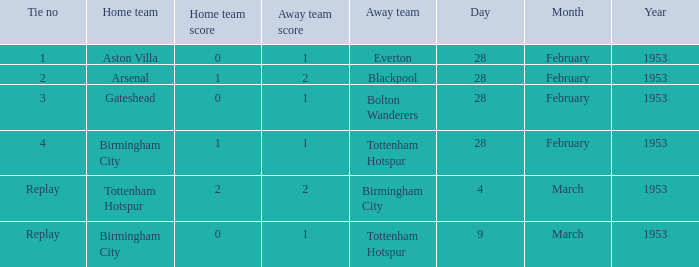Which Tie no has a Score of 0–1, and a Date of 9 march 1953? Replay. 